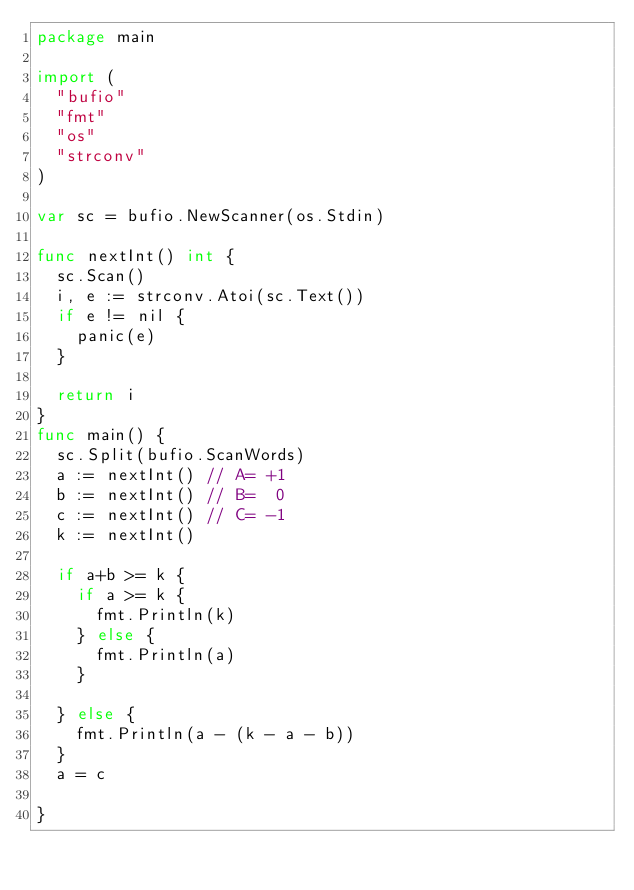<code> <loc_0><loc_0><loc_500><loc_500><_Go_>package main

import (
	"bufio"
	"fmt"
	"os"
	"strconv"
)

var sc = bufio.NewScanner(os.Stdin)

func nextInt() int {
	sc.Scan()
	i, e := strconv.Atoi(sc.Text())
	if e != nil {
		panic(e)
	}

	return i
}
func main() {
	sc.Split(bufio.ScanWords)
	a := nextInt() // A= +1
	b := nextInt() // B=  0
	c := nextInt() // C= -1
	k := nextInt()

	if a+b >= k {
		if a >= k {
			fmt.Println(k)
		} else {
			fmt.Println(a)
		}

	} else {
		fmt.Println(a - (k - a - b))
	}
	a = c

}
</code> 